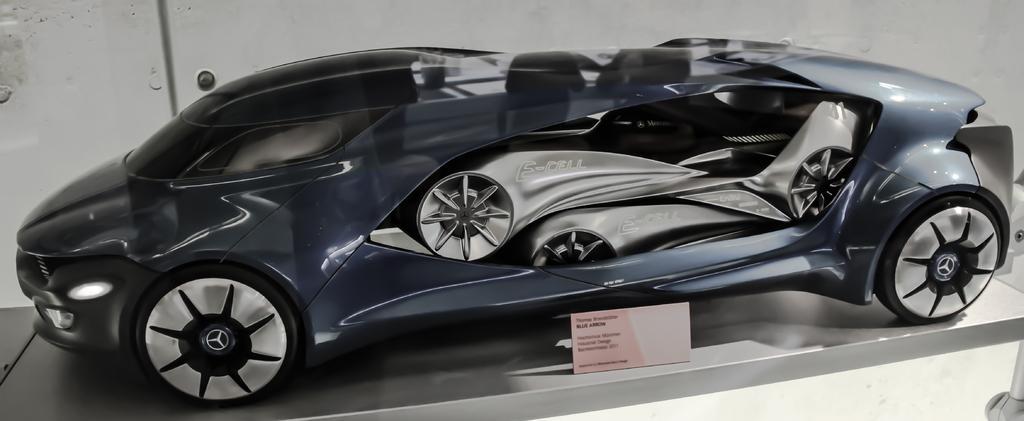Could you give a brief overview of what you see in this image? Here I can see a toy car. Beside this there is a small board on which I can see some text. In the background there is a wall. 